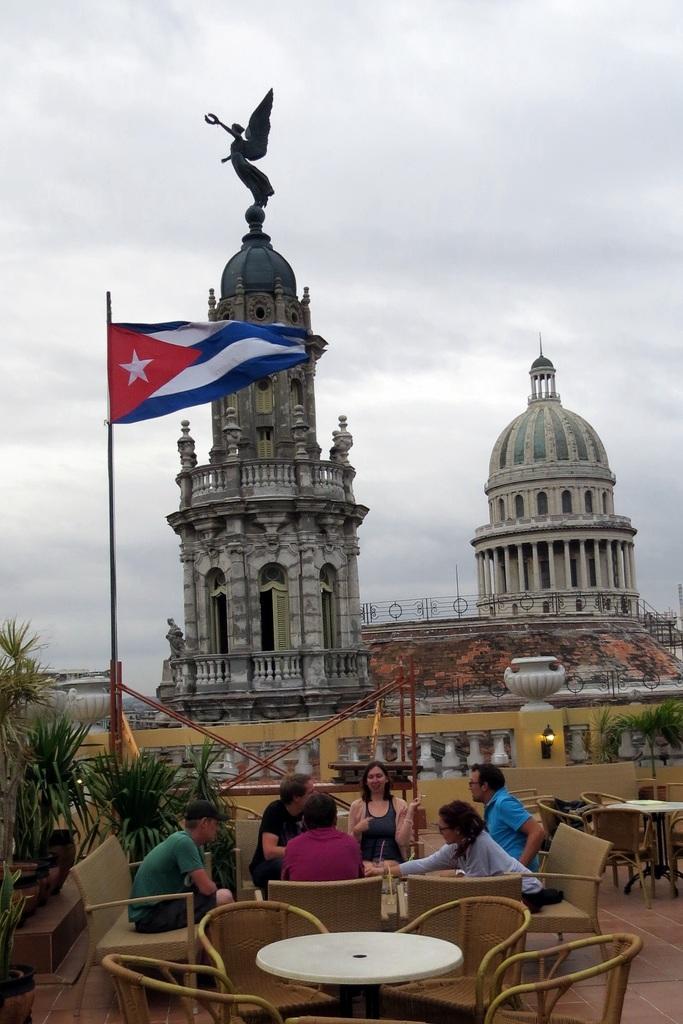In one or two sentences, can you explain what this image depicts? This images clicked outside. There is sky on the top and building in the middle. On that building there is a statue and on the left side there is a flag and shrubs. There are so many tables and chairs in the bottom. People are sitting on that chairs around the table. 